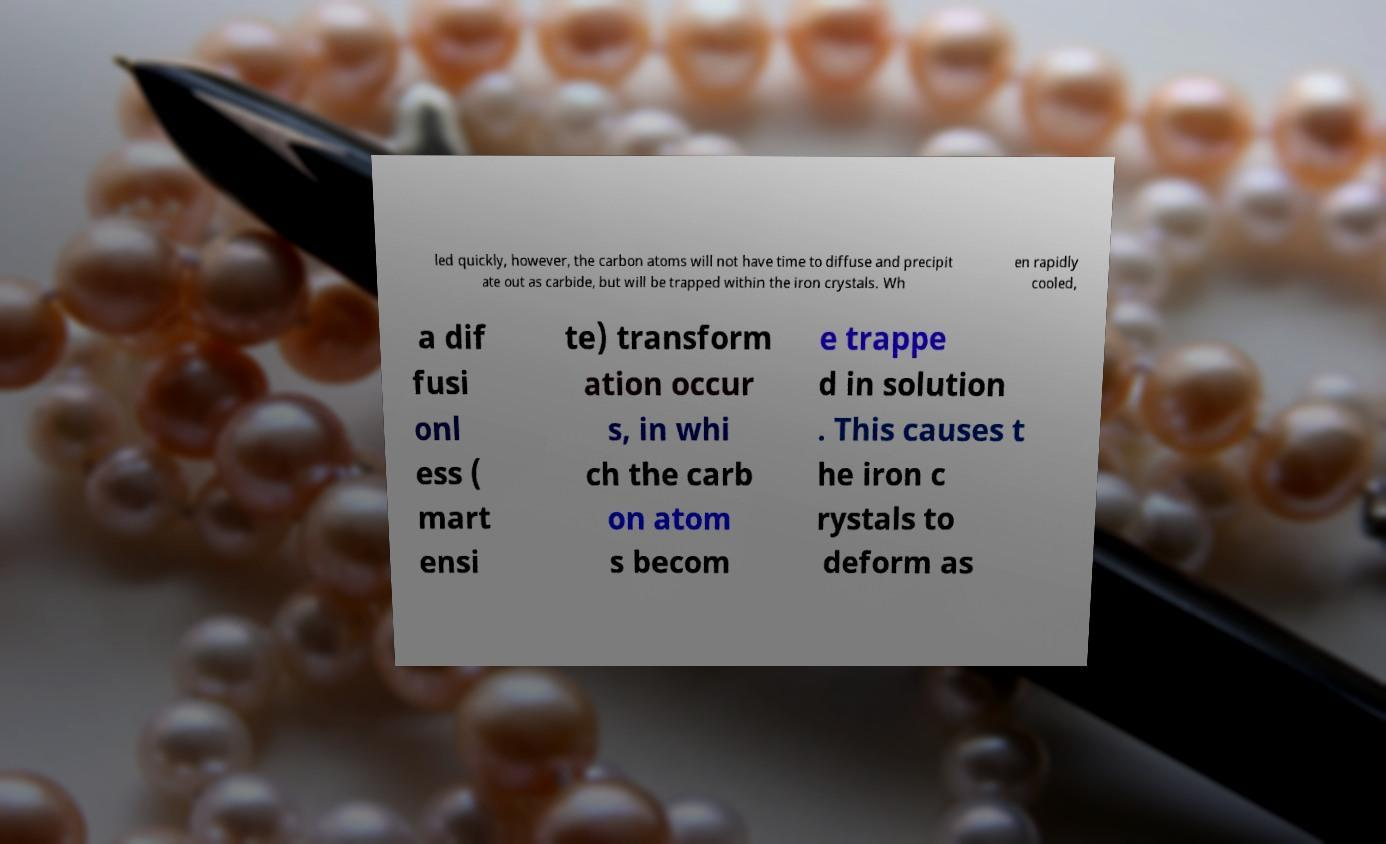Please read and relay the text visible in this image. What does it say? led quickly, however, the carbon atoms will not have time to diffuse and precipit ate out as carbide, but will be trapped within the iron crystals. Wh en rapidly cooled, a dif fusi onl ess ( mart ensi te) transform ation occur s, in whi ch the carb on atom s becom e trappe d in solution . This causes t he iron c rystals to deform as 